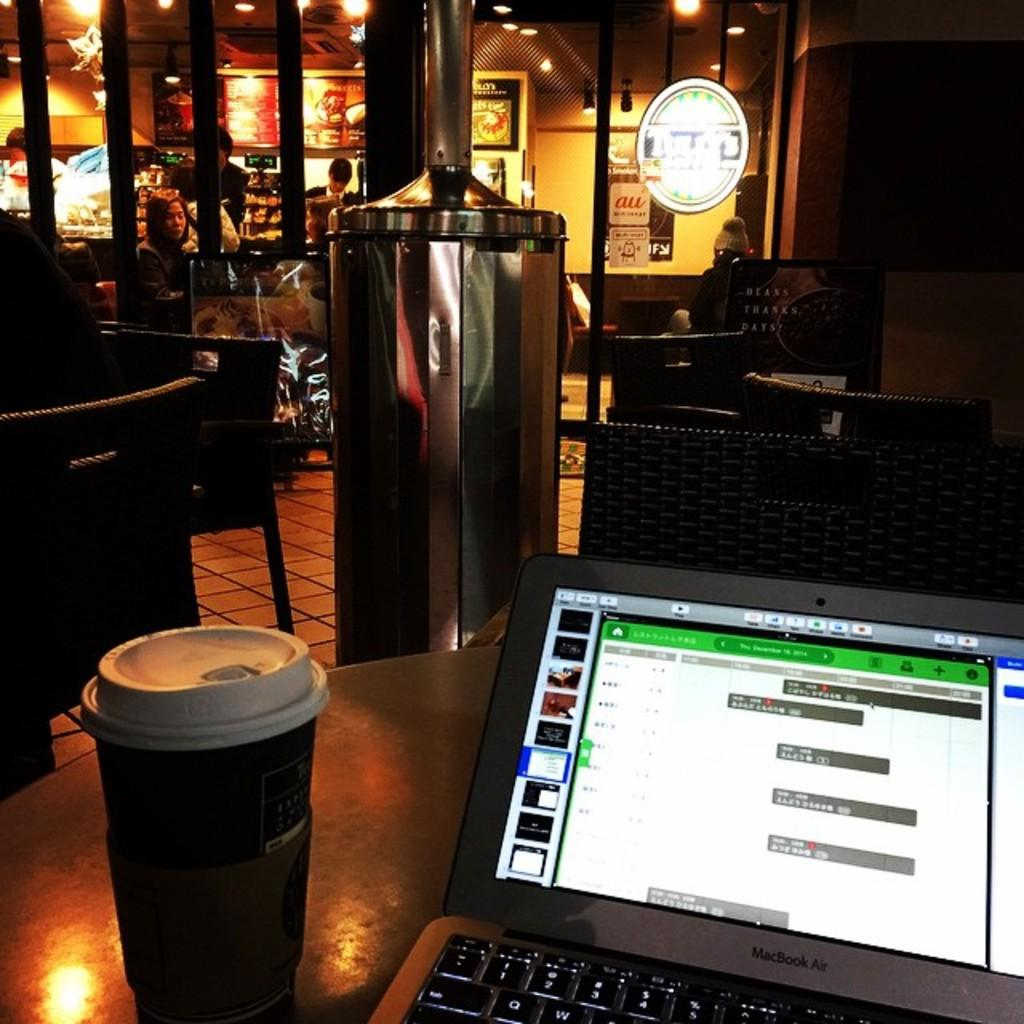Provide a one-sentence caption for the provided image. A Macbook Air and a coffee sit on a table at a dimly lit coffee shop in the evening. 